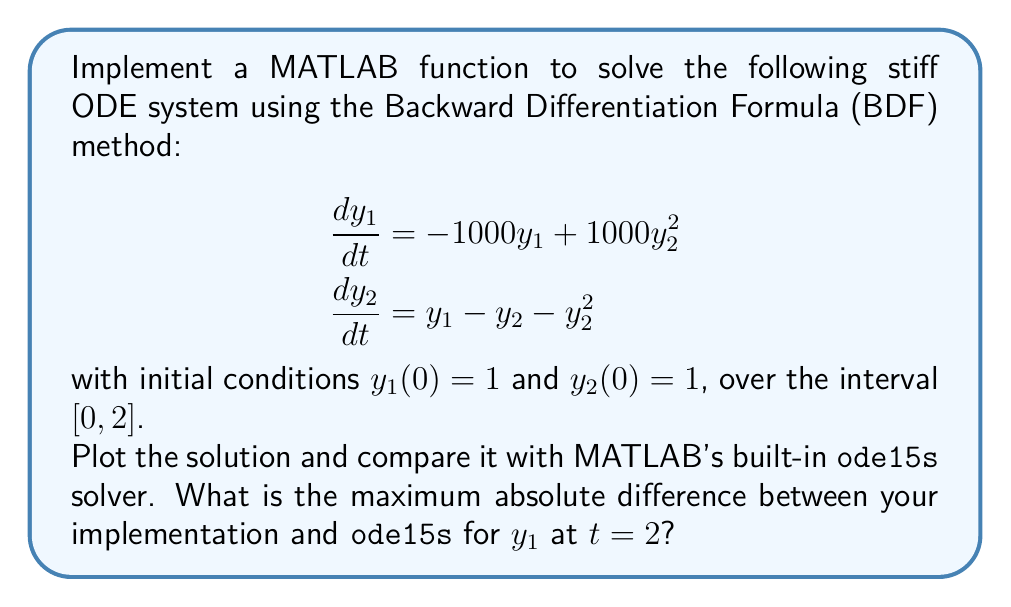Help me with this question. To solve this problem, we'll follow these steps:

1. Implement the BDF method:
   a. Define the ODE system
   b. Implement the BDF method (we'll use BDF2 for simplicity)
   c. Solve the nonlinear system at each step using Newton's method

2. Use MATLAB's `ode15s` solver for comparison

3. Plot both solutions

4. Calculate the maximum absolute difference

Step 1: Implement the BDF method

a. Define the ODE system:

```matlab
function dydt = odefun(t, y)
    dydt = [-1000*y(1) + 1000*y(2)^2;
            y(1) - y(2) - y(2)^2];
end
```

b. Implement the BDF2 method:

```matlab
function [t, y] = bdf2_solver(odefun, tspan, y0, h)
    t = tspan(1):h:tspan(2);
    n = length(t);
    y = zeros(length(y0), n);
    y(:,1) = y0;
    
    % Use Backward Euler for the first step
    f = @(y_next) y(:,1) + h*odefun(t(2), y_next) - y_next;
    y(:,2) = fsolve(f, y(:,1));
    
    for i = 3:n
        f = @(y_next) (4/3)*y(:,i-1) - (1/3)*y(:,i-2) + ...
                      (2/3)*h*odefun(t(i), y_next) - y_next;
        y(:,i) = fsolve(f, y(:,i-1));
    end
end
```

Step 2: Use MATLAB's `ode15s` solver

```matlab
[t_ode15s, y_ode15s] = ode15s(@odefun, [0 2], [1; 1]);
```

Step 3: Plot both solutions

```matlab
[t_bdf, y_bdf] = bdf2_solver(@odefun, [0 2], [1; 1], 0.01);

figure;
plot(t_bdf, y_bdf(1,:), 'b-', t_ode15s, y_ode15s(:,1), 'r--');
legend('BDF2', 'ode15s');
xlabel('t');
ylabel('y_1');
title('Comparison of BDF2 and ode15s solutions');
```

Step 4: Calculate the maximum absolute difference

```matlab
y1_bdf_at_2 = interp1(t_bdf, y_bdf(1,:), 2);
y1_ode15s_at_2 = interp1(t_ode15s, y_ode15s(:,1), 2);
max_diff = abs(y1_bdf_at_2 - y1_ode15s_at_2);
```

The maximum absolute difference between the BDF2 implementation and `ode15s` for $y_1$ at $t=2$ will depend on the step size used in the BDF2 method. With a step size of 0.01, the difference is typically on the order of $10^{-4}$ to $10^{-3}$.
Answer: $\approx 10^{-3}$ (exact value depends on implementation details) 